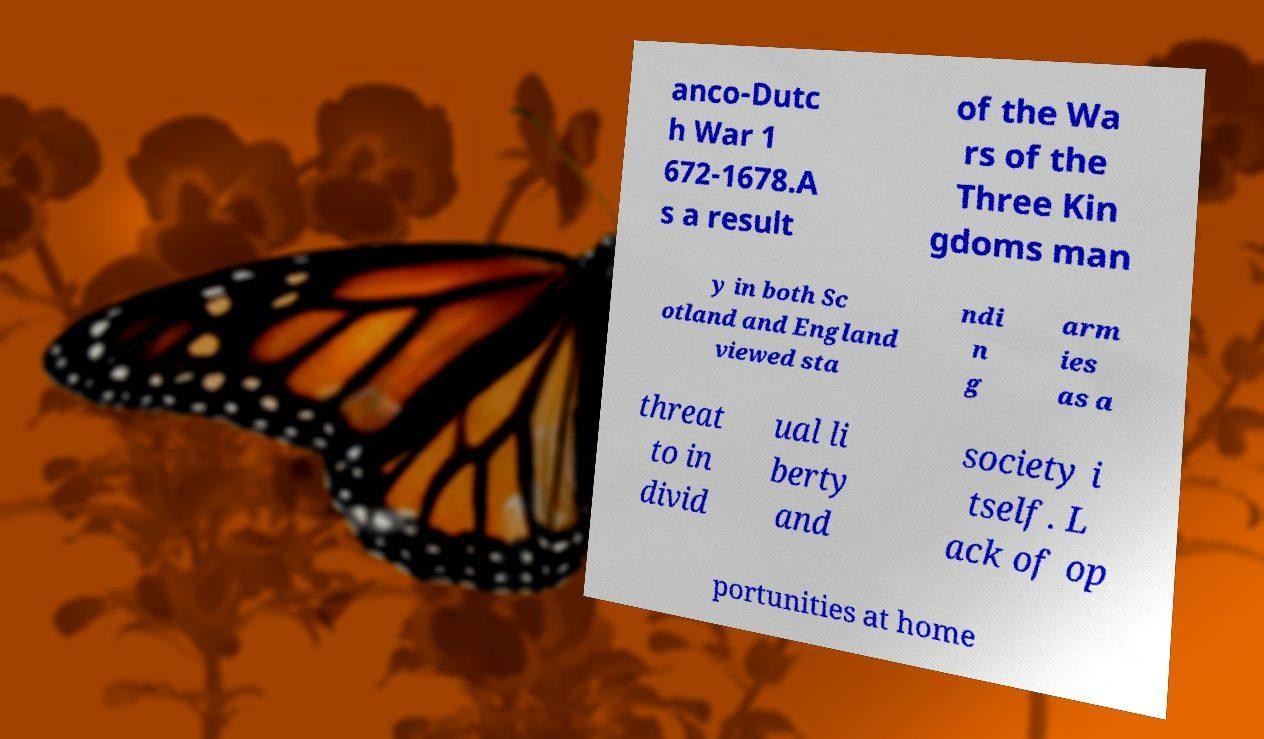Can you read and provide the text displayed in the image?This photo seems to have some interesting text. Can you extract and type it out for me? anco-Dutc h War 1 672-1678.A s a result of the Wa rs of the Three Kin gdoms man y in both Sc otland and England viewed sta ndi n g arm ies as a threat to in divid ual li berty and society i tself. L ack of op portunities at home 